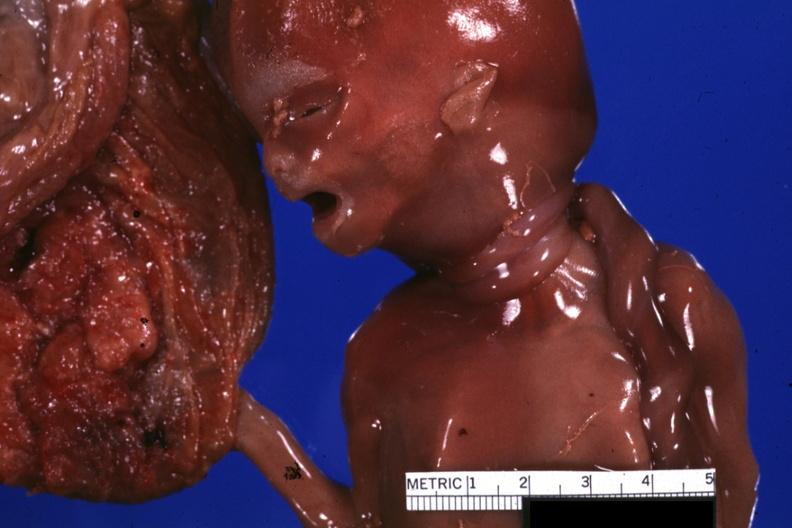s stillborn cord around neck present?
Answer the question using a single word or phrase. Yes 